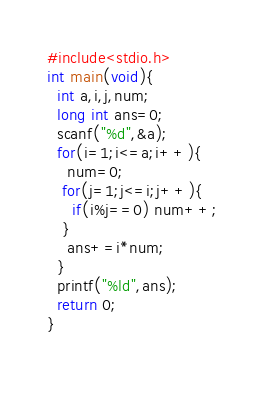<code> <loc_0><loc_0><loc_500><loc_500><_C_>#include<stdio.h>
int main(void){
  int a,i,j,num;
  long int ans=0;
  scanf("%d",&a);
  for(i=1;i<=a;i++){
    num=0;
   for(j=1;j<=i;j++){
     if(i%j==0) num++;
   }
    ans+=i*num;
  }
  printf("%ld",ans);
  return 0;
}

    </code> 